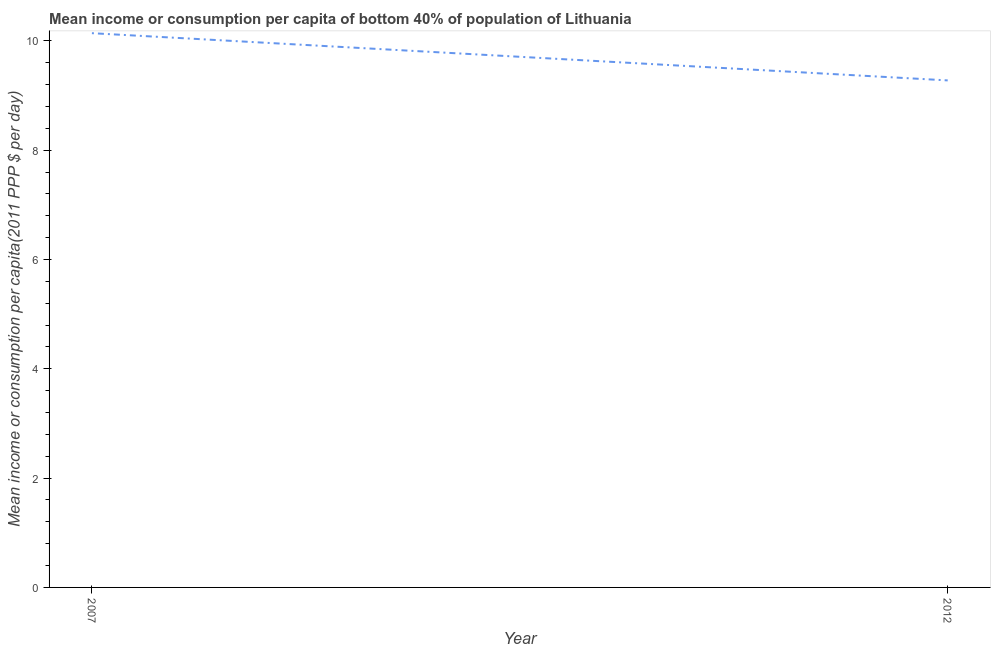What is the mean income or consumption in 2007?
Keep it short and to the point. 10.14. Across all years, what is the maximum mean income or consumption?
Keep it short and to the point. 10.14. Across all years, what is the minimum mean income or consumption?
Make the answer very short. 9.28. In which year was the mean income or consumption maximum?
Make the answer very short. 2007. In which year was the mean income or consumption minimum?
Your answer should be compact. 2012. What is the sum of the mean income or consumption?
Your response must be concise. 19.42. What is the difference between the mean income or consumption in 2007 and 2012?
Ensure brevity in your answer.  0.86. What is the average mean income or consumption per year?
Keep it short and to the point. 9.71. What is the median mean income or consumption?
Provide a short and direct response. 9.71. Do a majority of the years between 2012 and 2007 (inclusive) have mean income or consumption greater than 7.6 $?
Provide a short and direct response. No. What is the ratio of the mean income or consumption in 2007 to that in 2012?
Offer a very short reply. 1.09. In how many years, is the mean income or consumption greater than the average mean income or consumption taken over all years?
Offer a very short reply. 1. How many lines are there?
Give a very brief answer. 1. How many years are there in the graph?
Keep it short and to the point. 2. Does the graph contain any zero values?
Offer a terse response. No. Does the graph contain grids?
Make the answer very short. No. What is the title of the graph?
Keep it short and to the point. Mean income or consumption per capita of bottom 40% of population of Lithuania. What is the label or title of the X-axis?
Ensure brevity in your answer.  Year. What is the label or title of the Y-axis?
Your answer should be compact. Mean income or consumption per capita(2011 PPP $ per day). What is the Mean income or consumption per capita(2011 PPP $ per day) of 2007?
Keep it short and to the point. 10.14. What is the Mean income or consumption per capita(2011 PPP $ per day) in 2012?
Give a very brief answer. 9.28. What is the difference between the Mean income or consumption per capita(2011 PPP $ per day) in 2007 and 2012?
Ensure brevity in your answer.  0.86. What is the ratio of the Mean income or consumption per capita(2011 PPP $ per day) in 2007 to that in 2012?
Ensure brevity in your answer.  1.09. 